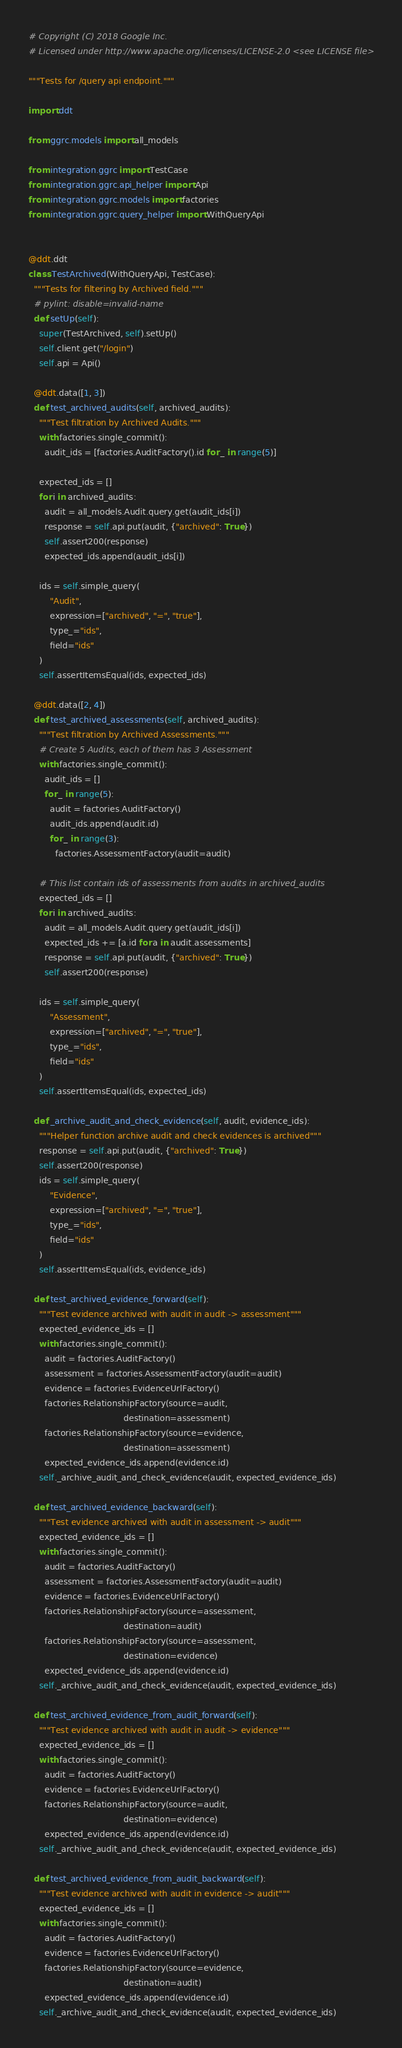Convert code to text. <code><loc_0><loc_0><loc_500><loc_500><_Python_># Copyright (C) 2018 Google Inc.
# Licensed under http://www.apache.org/licenses/LICENSE-2.0 <see LICENSE file>

"""Tests for /query api endpoint."""

import ddt

from ggrc.models import all_models

from integration.ggrc import TestCase
from integration.ggrc.api_helper import Api
from integration.ggrc.models import factories
from integration.ggrc.query_helper import WithQueryApi


@ddt.ddt
class TestArchived(WithQueryApi, TestCase):
  """Tests for filtering by Archived field."""
  # pylint: disable=invalid-name
  def setUp(self):
    super(TestArchived, self).setUp()
    self.client.get("/login")
    self.api = Api()

  @ddt.data([1, 3])
  def test_archived_audits(self, archived_audits):
    """Test filtration by Archived Audits."""
    with factories.single_commit():
      audit_ids = [factories.AuditFactory().id for _ in range(5)]

    expected_ids = []
    for i in archived_audits:
      audit = all_models.Audit.query.get(audit_ids[i])
      response = self.api.put(audit, {"archived": True})
      self.assert200(response)
      expected_ids.append(audit_ids[i])

    ids = self.simple_query(
        "Audit",
        expression=["archived", "=", "true"],
        type_="ids",
        field="ids"
    )
    self.assertItemsEqual(ids, expected_ids)

  @ddt.data([2, 4])
  def test_archived_assessments(self, archived_audits):
    """Test filtration by Archived Assessments."""
    # Create 5 Audits, each of them has 3 Assessment
    with factories.single_commit():
      audit_ids = []
      for _ in range(5):
        audit = factories.AuditFactory()
        audit_ids.append(audit.id)
        for _ in range(3):
          factories.AssessmentFactory(audit=audit)

    # This list contain ids of assessments from audits in archived_audits
    expected_ids = []
    for i in archived_audits:
      audit = all_models.Audit.query.get(audit_ids[i])
      expected_ids += [a.id for a in audit.assessments]
      response = self.api.put(audit, {"archived": True})
      self.assert200(response)

    ids = self.simple_query(
        "Assessment",
        expression=["archived", "=", "true"],
        type_="ids",
        field="ids"
    )
    self.assertItemsEqual(ids, expected_ids)

  def _archive_audit_and_check_evidence(self, audit, evidence_ids):
    """Helper function archive audit and check evidences is archived"""
    response = self.api.put(audit, {"archived": True})
    self.assert200(response)
    ids = self.simple_query(
        "Evidence",
        expression=["archived", "=", "true"],
        type_="ids",
        field="ids"
    )
    self.assertItemsEqual(ids, evidence_ids)

  def test_archived_evidence_forward(self):
    """Test evidence archived with audit in audit -> assessment"""
    expected_evidence_ids = []
    with factories.single_commit():
      audit = factories.AuditFactory()
      assessment = factories.AssessmentFactory(audit=audit)
      evidence = factories.EvidenceUrlFactory()
      factories.RelationshipFactory(source=audit,
                                    destination=assessment)
      factories.RelationshipFactory(source=evidence,
                                    destination=assessment)
      expected_evidence_ids.append(evidence.id)
    self._archive_audit_and_check_evidence(audit, expected_evidence_ids)

  def test_archived_evidence_backward(self):
    """Test evidence archived with audit in assessment -> audit"""
    expected_evidence_ids = []
    with factories.single_commit():
      audit = factories.AuditFactory()
      assessment = factories.AssessmentFactory(audit=audit)
      evidence = factories.EvidenceUrlFactory()
      factories.RelationshipFactory(source=assessment,
                                    destination=audit)
      factories.RelationshipFactory(source=assessment,
                                    destination=evidence)
      expected_evidence_ids.append(evidence.id)
    self._archive_audit_and_check_evidence(audit, expected_evidence_ids)

  def test_archived_evidence_from_audit_forward(self):
    """Test evidence archived with audit in audit -> evidence"""
    expected_evidence_ids = []
    with factories.single_commit():
      audit = factories.AuditFactory()
      evidence = factories.EvidenceUrlFactory()
      factories.RelationshipFactory(source=audit,
                                    destination=evidence)
      expected_evidence_ids.append(evidence.id)
    self._archive_audit_and_check_evidence(audit, expected_evidence_ids)

  def test_archived_evidence_from_audit_backward(self):
    """Test evidence archived with audit in evidence -> audit"""
    expected_evidence_ids = []
    with factories.single_commit():
      audit = factories.AuditFactory()
      evidence = factories.EvidenceUrlFactory()
      factories.RelationshipFactory(source=evidence,
                                    destination=audit)
      expected_evidence_ids.append(evidence.id)
    self._archive_audit_and_check_evidence(audit, expected_evidence_ids)
</code> 